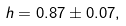<formula> <loc_0><loc_0><loc_500><loc_500>h = 0 . 8 7 \pm 0 . 0 7 ,</formula> 